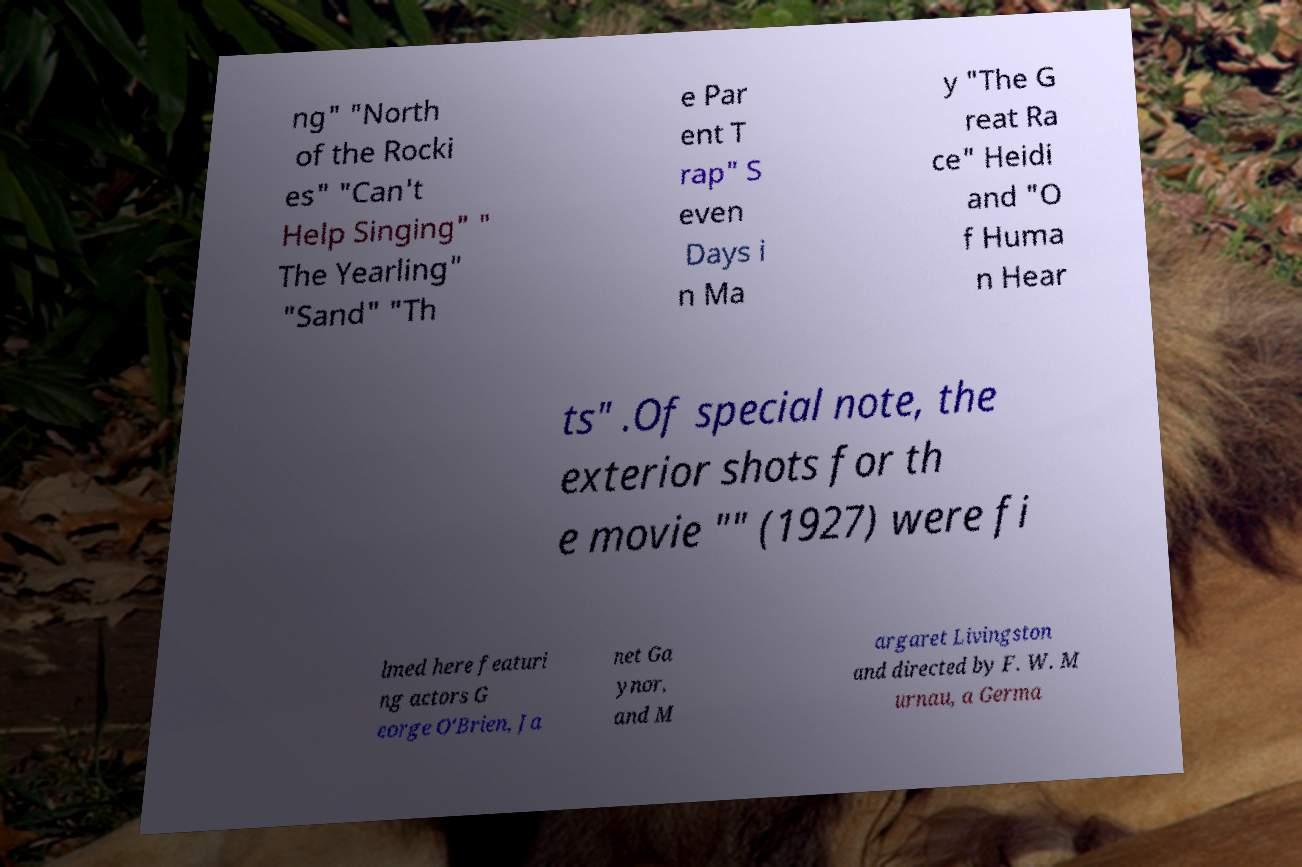I need the written content from this picture converted into text. Can you do that? ng" "North of the Rocki es" "Can't Help Singing" " The Yearling" "Sand" "Th e Par ent T rap" S even Days i n Ma y "The G reat Ra ce" Heidi and "O f Huma n Hear ts" .Of special note, the exterior shots for th e movie "" (1927) were fi lmed here featuri ng actors G eorge O'Brien, Ja net Ga ynor, and M argaret Livingston and directed by F. W. M urnau, a Germa 